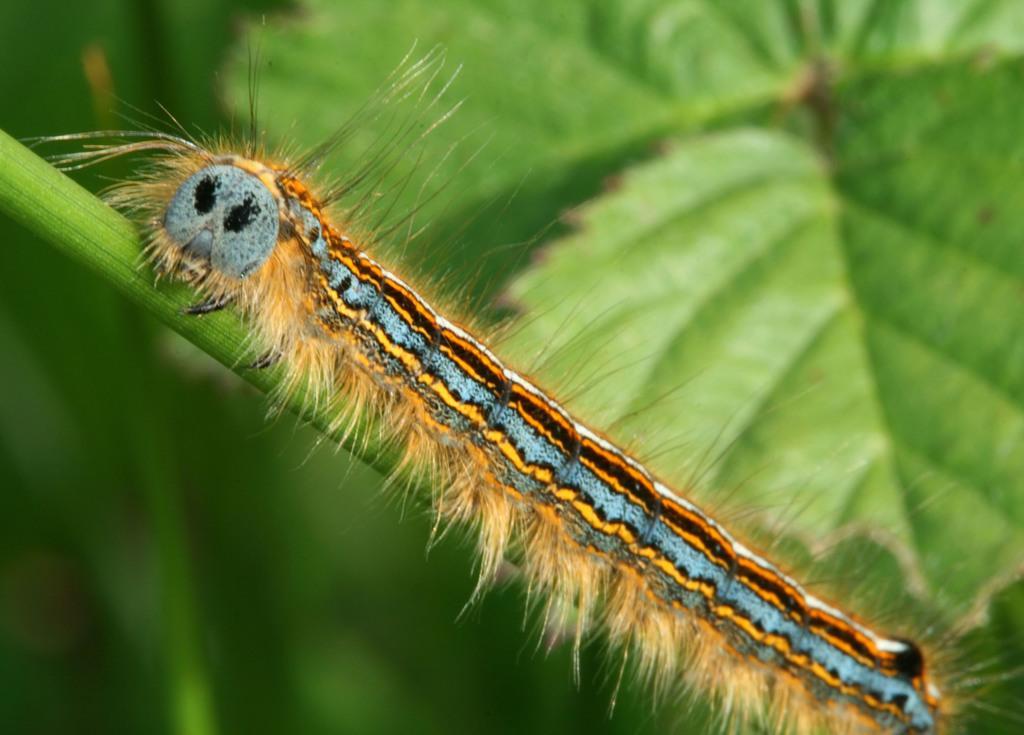How would you summarize this image in a sentence or two? In this picture we can see a lackey moth caterpillar on the branch and behind the caterpillar there are leaves. 